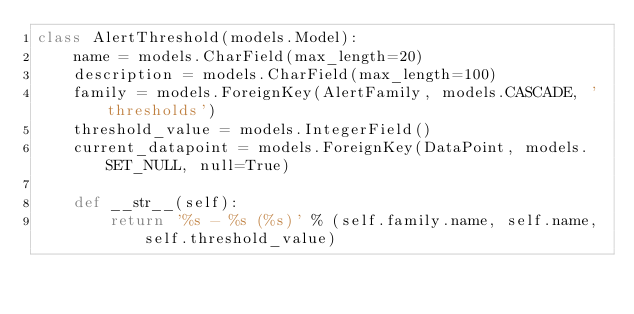<code> <loc_0><loc_0><loc_500><loc_500><_Python_>class AlertThreshold(models.Model):
    name = models.CharField(max_length=20)
    description = models.CharField(max_length=100)
    family = models.ForeignKey(AlertFamily, models.CASCADE, 'thresholds')
    threshold_value = models.IntegerField()
    current_datapoint = models.ForeignKey(DataPoint, models.SET_NULL, null=True)

    def __str__(self):
        return '%s - %s (%s)' % (self.family.name, self.name, self.threshold_value)
</code> 